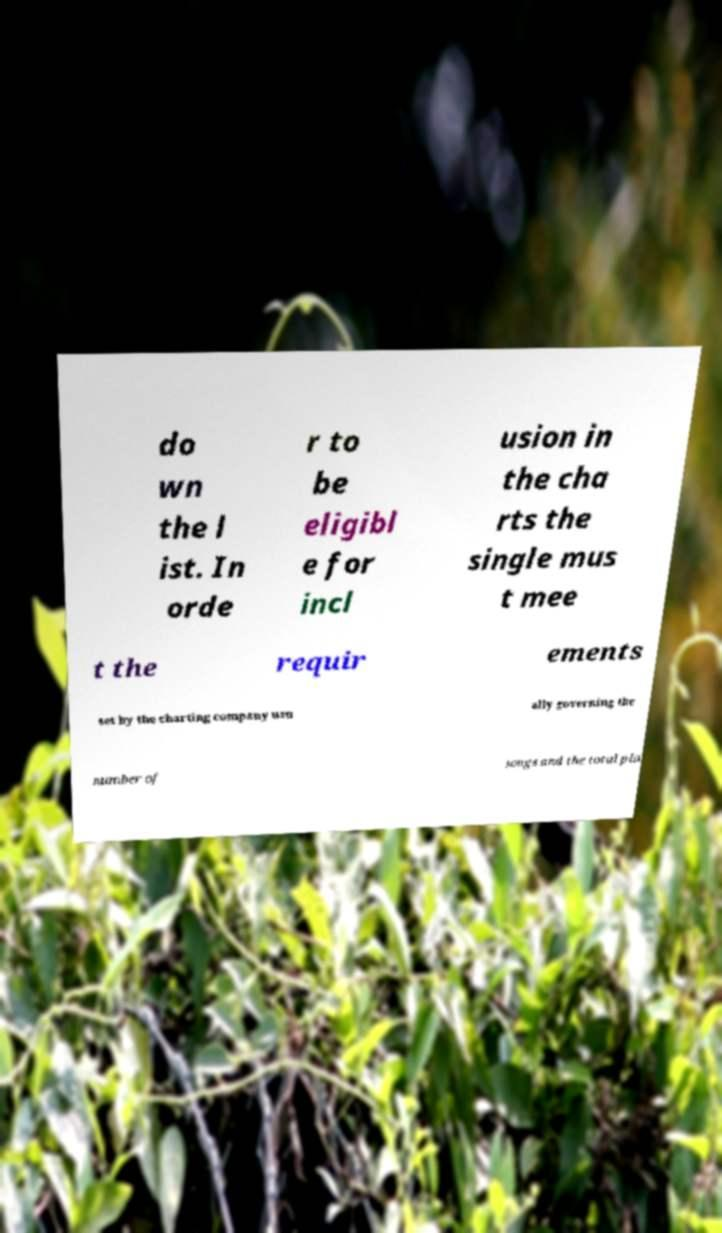Please identify and transcribe the text found in this image. do wn the l ist. In orde r to be eligibl e for incl usion in the cha rts the single mus t mee t the requir ements set by the charting company usu ally governing the number of songs and the total pla 